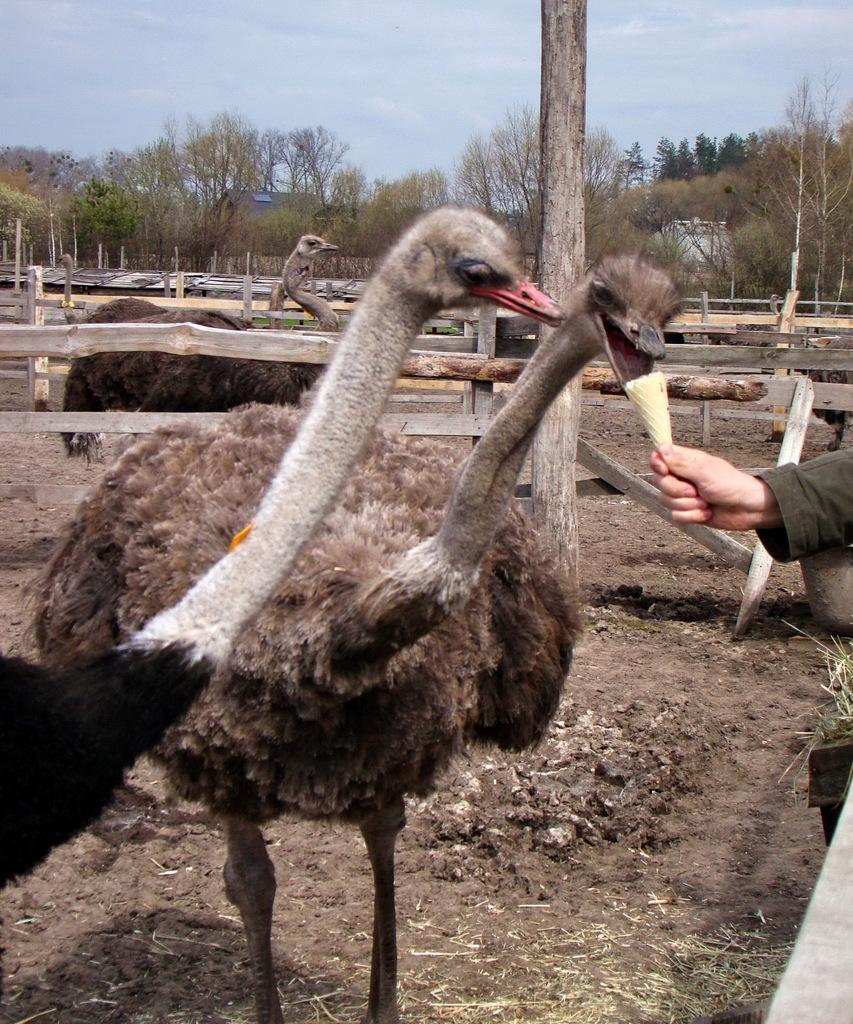What type of animals can be seen in the image? There are many ostriches in the image. What type of vegetation is present in the image? There are trees in the image. What type of barrier can be seen in the image? There is a wooden fence in the image. What is the weather like in the image? The sky is cloudy in the image. What is a human hand holding in the image? There is a human hand holding an ice cream cone in the image. What type of thread is being used by the ostriches to communicate in the image? There is no thread present in the image, and the ostriches are not communicating with each other. 